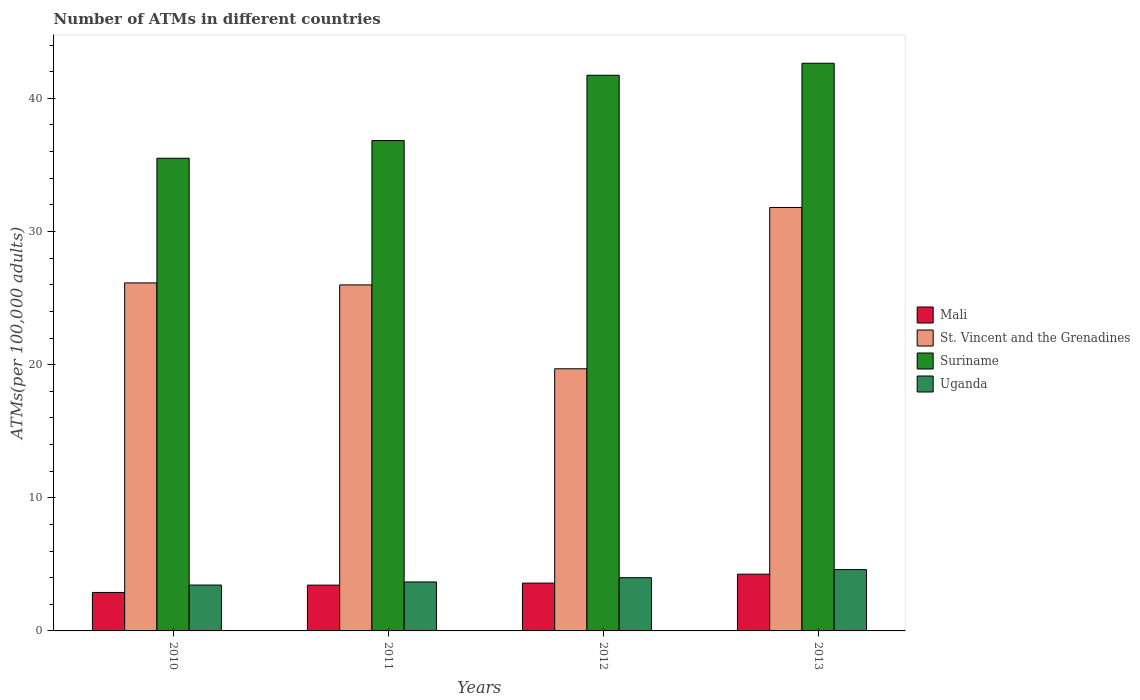How many different coloured bars are there?
Offer a very short reply. 4. How many bars are there on the 4th tick from the right?
Your answer should be very brief. 4. In how many cases, is the number of bars for a given year not equal to the number of legend labels?
Your answer should be compact. 0. What is the number of ATMs in Suriname in 2013?
Offer a very short reply. 42.64. Across all years, what is the maximum number of ATMs in St. Vincent and the Grenadines?
Provide a short and direct response. 31.81. Across all years, what is the minimum number of ATMs in Uganda?
Make the answer very short. 3.45. What is the total number of ATMs in Suriname in the graph?
Make the answer very short. 156.71. What is the difference between the number of ATMs in Mali in 2011 and that in 2013?
Keep it short and to the point. -0.82. What is the difference between the number of ATMs in Uganda in 2011 and the number of ATMs in St. Vincent and the Grenadines in 2010?
Your answer should be compact. -22.46. What is the average number of ATMs in St. Vincent and the Grenadines per year?
Offer a very short reply. 25.91. In the year 2010, what is the difference between the number of ATMs in Uganda and number of ATMs in Mali?
Your answer should be compact. 0.56. What is the ratio of the number of ATMs in Mali in 2012 to that in 2013?
Keep it short and to the point. 0.84. Is the difference between the number of ATMs in Uganda in 2011 and 2012 greater than the difference between the number of ATMs in Mali in 2011 and 2012?
Your answer should be very brief. No. What is the difference between the highest and the second highest number of ATMs in St. Vincent and the Grenadines?
Your answer should be very brief. 5.67. What is the difference between the highest and the lowest number of ATMs in Mali?
Provide a succinct answer. 1.37. In how many years, is the number of ATMs in Uganda greater than the average number of ATMs in Uganda taken over all years?
Provide a short and direct response. 2. Is it the case that in every year, the sum of the number of ATMs in Uganda and number of ATMs in St. Vincent and the Grenadines is greater than the sum of number of ATMs in Mali and number of ATMs in Suriname?
Offer a terse response. Yes. What does the 1st bar from the left in 2011 represents?
Provide a short and direct response. Mali. What does the 1st bar from the right in 2010 represents?
Ensure brevity in your answer.  Uganda. Is it the case that in every year, the sum of the number of ATMs in St. Vincent and the Grenadines and number of ATMs in Mali is greater than the number of ATMs in Suriname?
Your response must be concise. No. Are all the bars in the graph horizontal?
Offer a very short reply. No. How many years are there in the graph?
Make the answer very short. 4. Are the values on the major ticks of Y-axis written in scientific E-notation?
Provide a short and direct response. No. Does the graph contain any zero values?
Offer a terse response. No. Does the graph contain grids?
Make the answer very short. No. How many legend labels are there?
Provide a short and direct response. 4. How are the legend labels stacked?
Keep it short and to the point. Vertical. What is the title of the graph?
Provide a succinct answer. Number of ATMs in different countries. Does "Peru" appear as one of the legend labels in the graph?
Give a very brief answer. No. What is the label or title of the Y-axis?
Make the answer very short. ATMs(per 100,0 adults). What is the ATMs(per 100,000 adults) in Mali in 2010?
Provide a succinct answer. 2.89. What is the ATMs(per 100,000 adults) of St. Vincent and the Grenadines in 2010?
Your answer should be very brief. 26.14. What is the ATMs(per 100,000 adults) of Suriname in 2010?
Keep it short and to the point. 35.5. What is the ATMs(per 100,000 adults) of Uganda in 2010?
Your answer should be compact. 3.45. What is the ATMs(per 100,000 adults) of Mali in 2011?
Your response must be concise. 3.44. What is the ATMs(per 100,000 adults) of St. Vincent and the Grenadines in 2011?
Offer a very short reply. 25.99. What is the ATMs(per 100,000 adults) of Suriname in 2011?
Your answer should be compact. 36.83. What is the ATMs(per 100,000 adults) in Uganda in 2011?
Your answer should be compact. 3.68. What is the ATMs(per 100,000 adults) of Mali in 2012?
Make the answer very short. 3.59. What is the ATMs(per 100,000 adults) of St. Vincent and the Grenadines in 2012?
Offer a very short reply. 19.69. What is the ATMs(per 100,000 adults) of Suriname in 2012?
Your response must be concise. 41.73. What is the ATMs(per 100,000 adults) of Uganda in 2012?
Provide a succinct answer. 4. What is the ATMs(per 100,000 adults) in Mali in 2013?
Give a very brief answer. 4.26. What is the ATMs(per 100,000 adults) of St. Vincent and the Grenadines in 2013?
Ensure brevity in your answer.  31.81. What is the ATMs(per 100,000 adults) in Suriname in 2013?
Your answer should be compact. 42.64. What is the ATMs(per 100,000 adults) of Uganda in 2013?
Ensure brevity in your answer.  4.6. Across all years, what is the maximum ATMs(per 100,000 adults) of Mali?
Ensure brevity in your answer.  4.26. Across all years, what is the maximum ATMs(per 100,000 adults) of St. Vincent and the Grenadines?
Provide a succinct answer. 31.81. Across all years, what is the maximum ATMs(per 100,000 adults) in Suriname?
Give a very brief answer. 42.64. Across all years, what is the maximum ATMs(per 100,000 adults) of Uganda?
Offer a terse response. 4.6. Across all years, what is the minimum ATMs(per 100,000 adults) of Mali?
Your answer should be compact. 2.89. Across all years, what is the minimum ATMs(per 100,000 adults) in St. Vincent and the Grenadines?
Keep it short and to the point. 19.69. Across all years, what is the minimum ATMs(per 100,000 adults) of Suriname?
Make the answer very short. 35.5. Across all years, what is the minimum ATMs(per 100,000 adults) in Uganda?
Ensure brevity in your answer.  3.45. What is the total ATMs(per 100,000 adults) of Mali in the graph?
Your response must be concise. 14.18. What is the total ATMs(per 100,000 adults) of St. Vincent and the Grenadines in the graph?
Your response must be concise. 103.62. What is the total ATMs(per 100,000 adults) in Suriname in the graph?
Ensure brevity in your answer.  156.71. What is the total ATMs(per 100,000 adults) of Uganda in the graph?
Offer a very short reply. 15.73. What is the difference between the ATMs(per 100,000 adults) in Mali in 2010 and that in 2011?
Provide a succinct answer. -0.55. What is the difference between the ATMs(per 100,000 adults) in St. Vincent and the Grenadines in 2010 and that in 2011?
Make the answer very short. 0.15. What is the difference between the ATMs(per 100,000 adults) of Suriname in 2010 and that in 2011?
Your response must be concise. -1.33. What is the difference between the ATMs(per 100,000 adults) in Uganda in 2010 and that in 2011?
Keep it short and to the point. -0.23. What is the difference between the ATMs(per 100,000 adults) of Mali in 2010 and that in 2012?
Provide a short and direct response. -0.7. What is the difference between the ATMs(per 100,000 adults) in St. Vincent and the Grenadines in 2010 and that in 2012?
Your answer should be very brief. 6.45. What is the difference between the ATMs(per 100,000 adults) in Suriname in 2010 and that in 2012?
Offer a very short reply. -6.23. What is the difference between the ATMs(per 100,000 adults) of Uganda in 2010 and that in 2012?
Your answer should be very brief. -0.55. What is the difference between the ATMs(per 100,000 adults) in Mali in 2010 and that in 2013?
Provide a succinct answer. -1.37. What is the difference between the ATMs(per 100,000 adults) of St. Vincent and the Grenadines in 2010 and that in 2013?
Provide a short and direct response. -5.67. What is the difference between the ATMs(per 100,000 adults) of Suriname in 2010 and that in 2013?
Give a very brief answer. -7.13. What is the difference between the ATMs(per 100,000 adults) in Uganda in 2010 and that in 2013?
Keep it short and to the point. -1.16. What is the difference between the ATMs(per 100,000 adults) in Mali in 2011 and that in 2012?
Your answer should be very brief. -0.15. What is the difference between the ATMs(per 100,000 adults) of St. Vincent and the Grenadines in 2011 and that in 2012?
Keep it short and to the point. 6.3. What is the difference between the ATMs(per 100,000 adults) of Suriname in 2011 and that in 2012?
Your response must be concise. -4.9. What is the difference between the ATMs(per 100,000 adults) in Uganda in 2011 and that in 2012?
Make the answer very short. -0.32. What is the difference between the ATMs(per 100,000 adults) of Mali in 2011 and that in 2013?
Offer a very short reply. -0.82. What is the difference between the ATMs(per 100,000 adults) in St. Vincent and the Grenadines in 2011 and that in 2013?
Your answer should be compact. -5.82. What is the difference between the ATMs(per 100,000 adults) in Suriname in 2011 and that in 2013?
Provide a succinct answer. -5.8. What is the difference between the ATMs(per 100,000 adults) in Uganda in 2011 and that in 2013?
Your answer should be very brief. -0.93. What is the difference between the ATMs(per 100,000 adults) in Mali in 2012 and that in 2013?
Make the answer very short. -0.67. What is the difference between the ATMs(per 100,000 adults) in St. Vincent and the Grenadines in 2012 and that in 2013?
Your response must be concise. -12.12. What is the difference between the ATMs(per 100,000 adults) of Suriname in 2012 and that in 2013?
Your answer should be compact. -0.9. What is the difference between the ATMs(per 100,000 adults) of Uganda in 2012 and that in 2013?
Offer a very short reply. -0.61. What is the difference between the ATMs(per 100,000 adults) of Mali in 2010 and the ATMs(per 100,000 adults) of St. Vincent and the Grenadines in 2011?
Ensure brevity in your answer.  -23.1. What is the difference between the ATMs(per 100,000 adults) in Mali in 2010 and the ATMs(per 100,000 adults) in Suriname in 2011?
Your answer should be very brief. -33.95. What is the difference between the ATMs(per 100,000 adults) of Mali in 2010 and the ATMs(per 100,000 adults) of Uganda in 2011?
Provide a short and direct response. -0.79. What is the difference between the ATMs(per 100,000 adults) of St. Vincent and the Grenadines in 2010 and the ATMs(per 100,000 adults) of Suriname in 2011?
Ensure brevity in your answer.  -10.7. What is the difference between the ATMs(per 100,000 adults) in St. Vincent and the Grenadines in 2010 and the ATMs(per 100,000 adults) in Uganda in 2011?
Give a very brief answer. 22.46. What is the difference between the ATMs(per 100,000 adults) of Suriname in 2010 and the ATMs(per 100,000 adults) of Uganda in 2011?
Provide a succinct answer. 31.82. What is the difference between the ATMs(per 100,000 adults) of Mali in 2010 and the ATMs(per 100,000 adults) of St. Vincent and the Grenadines in 2012?
Give a very brief answer. -16.8. What is the difference between the ATMs(per 100,000 adults) of Mali in 2010 and the ATMs(per 100,000 adults) of Suriname in 2012?
Keep it short and to the point. -38.84. What is the difference between the ATMs(per 100,000 adults) of Mali in 2010 and the ATMs(per 100,000 adults) of Uganda in 2012?
Give a very brief answer. -1.11. What is the difference between the ATMs(per 100,000 adults) of St. Vincent and the Grenadines in 2010 and the ATMs(per 100,000 adults) of Suriname in 2012?
Your answer should be compact. -15.6. What is the difference between the ATMs(per 100,000 adults) in St. Vincent and the Grenadines in 2010 and the ATMs(per 100,000 adults) in Uganda in 2012?
Keep it short and to the point. 22.14. What is the difference between the ATMs(per 100,000 adults) of Suriname in 2010 and the ATMs(per 100,000 adults) of Uganda in 2012?
Your answer should be compact. 31.5. What is the difference between the ATMs(per 100,000 adults) of Mali in 2010 and the ATMs(per 100,000 adults) of St. Vincent and the Grenadines in 2013?
Keep it short and to the point. -28.92. What is the difference between the ATMs(per 100,000 adults) of Mali in 2010 and the ATMs(per 100,000 adults) of Suriname in 2013?
Keep it short and to the point. -39.75. What is the difference between the ATMs(per 100,000 adults) of Mali in 2010 and the ATMs(per 100,000 adults) of Uganda in 2013?
Offer a terse response. -1.72. What is the difference between the ATMs(per 100,000 adults) of St. Vincent and the Grenadines in 2010 and the ATMs(per 100,000 adults) of Suriname in 2013?
Your answer should be very brief. -16.5. What is the difference between the ATMs(per 100,000 adults) in St. Vincent and the Grenadines in 2010 and the ATMs(per 100,000 adults) in Uganda in 2013?
Give a very brief answer. 21.53. What is the difference between the ATMs(per 100,000 adults) of Suriname in 2010 and the ATMs(per 100,000 adults) of Uganda in 2013?
Provide a short and direct response. 30.9. What is the difference between the ATMs(per 100,000 adults) of Mali in 2011 and the ATMs(per 100,000 adults) of St. Vincent and the Grenadines in 2012?
Make the answer very short. -16.25. What is the difference between the ATMs(per 100,000 adults) of Mali in 2011 and the ATMs(per 100,000 adults) of Suriname in 2012?
Your answer should be compact. -38.29. What is the difference between the ATMs(per 100,000 adults) of Mali in 2011 and the ATMs(per 100,000 adults) of Uganda in 2012?
Your answer should be very brief. -0.56. What is the difference between the ATMs(per 100,000 adults) of St. Vincent and the Grenadines in 2011 and the ATMs(per 100,000 adults) of Suriname in 2012?
Make the answer very short. -15.75. What is the difference between the ATMs(per 100,000 adults) in St. Vincent and the Grenadines in 2011 and the ATMs(per 100,000 adults) in Uganda in 2012?
Provide a succinct answer. 21.99. What is the difference between the ATMs(per 100,000 adults) in Suriname in 2011 and the ATMs(per 100,000 adults) in Uganda in 2012?
Offer a terse response. 32.84. What is the difference between the ATMs(per 100,000 adults) of Mali in 2011 and the ATMs(per 100,000 adults) of St. Vincent and the Grenadines in 2013?
Your response must be concise. -28.37. What is the difference between the ATMs(per 100,000 adults) of Mali in 2011 and the ATMs(per 100,000 adults) of Suriname in 2013?
Your answer should be very brief. -39.2. What is the difference between the ATMs(per 100,000 adults) of Mali in 2011 and the ATMs(per 100,000 adults) of Uganda in 2013?
Your answer should be very brief. -1.17. What is the difference between the ATMs(per 100,000 adults) in St. Vincent and the Grenadines in 2011 and the ATMs(per 100,000 adults) in Suriname in 2013?
Your answer should be very brief. -16.65. What is the difference between the ATMs(per 100,000 adults) in St. Vincent and the Grenadines in 2011 and the ATMs(per 100,000 adults) in Uganda in 2013?
Provide a short and direct response. 21.38. What is the difference between the ATMs(per 100,000 adults) of Suriname in 2011 and the ATMs(per 100,000 adults) of Uganda in 2013?
Your answer should be very brief. 32.23. What is the difference between the ATMs(per 100,000 adults) in Mali in 2012 and the ATMs(per 100,000 adults) in St. Vincent and the Grenadines in 2013?
Give a very brief answer. -28.21. What is the difference between the ATMs(per 100,000 adults) in Mali in 2012 and the ATMs(per 100,000 adults) in Suriname in 2013?
Provide a short and direct response. -39.04. What is the difference between the ATMs(per 100,000 adults) in Mali in 2012 and the ATMs(per 100,000 adults) in Uganda in 2013?
Make the answer very short. -1.01. What is the difference between the ATMs(per 100,000 adults) of St. Vincent and the Grenadines in 2012 and the ATMs(per 100,000 adults) of Suriname in 2013?
Your answer should be very brief. -22.95. What is the difference between the ATMs(per 100,000 adults) of St. Vincent and the Grenadines in 2012 and the ATMs(per 100,000 adults) of Uganda in 2013?
Keep it short and to the point. 15.09. What is the difference between the ATMs(per 100,000 adults) in Suriname in 2012 and the ATMs(per 100,000 adults) in Uganda in 2013?
Offer a terse response. 37.13. What is the average ATMs(per 100,000 adults) in Mali per year?
Make the answer very short. 3.55. What is the average ATMs(per 100,000 adults) in St. Vincent and the Grenadines per year?
Your response must be concise. 25.91. What is the average ATMs(per 100,000 adults) of Suriname per year?
Give a very brief answer. 39.18. What is the average ATMs(per 100,000 adults) of Uganda per year?
Offer a terse response. 3.93. In the year 2010, what is the difference between the ATMs(per 100,000 adults) of Mali and ATMs(per 100,000 adults) of St. Vincent and the Grenadines?
Your answer should be compact. -23.25. In the year 2010, what is the difference between the ATMs(per 100,000 adults) of Mali and ATMs(per 100,000 adults) of Suriname?
Provide a succinct answer. -32.61. In the year 2010, what is the difference between the ATMs(per 100,000 adults) of Mali and ATMs(per 100,000 adults) of Uganda?
Your response must be concise. -0.56. In the year 2010, what is the difference between the ATMs(per 100,000 adults) of St. Vincent and the Grenadines and ATMs(per 100,000 adults) of Suriname?
Offer a very short reply. -9.36. In the year 2010, what is the difference between the ATMs(per 100,000 adults) of St. Vincent and the Grenadines and ATMs(per 100,000 adults) of Uganda?
Give a very brief answer. 22.69. In the year 2010, what is the difference between the ATMs(per 100,000 adults) in Suriname and ATMs(per 100,000 adults) in Uganda?
Provide a succinct answer. 32.06. In the year 2011, what is the difference between the ATMs(per 100,000 adults) of Mali and ATMs(per 100,000 adults) of St. Vincent and the Grenadines?
Offer a terse response. -22.55. In the year 2011, what is the difference between the ATMs(per 100,000 adults) in Mali and ATMs(per 100,000 adults) in Suriname?
Your response must be concise. -33.4. In the year 2011, what is the difference between the ATMs(per 100,000 adults) in Mali and ATMs(per 100,000 adults) in Uganda?
Make the answer very short. -0.24. In the year 2011, what is the difference between the ATMs(per 100,000 adults) in St. Vincent and the Grenadines and ATMs(per 100,000 adults) in Suriname?
Your response must be concise. -10.85. In the year 2011, what is the difference between the ATMs(per 100,000 adults) of St. Vincent and the Grenadines and ATMs(per 100,000 adults) of Uganda?
Provide a succinct answer. 22.31. In the year 2011, what is the difference between the ATMs(per 100,000 adults) of Suriname and ATMs(per 100,000 adults) of Uganda?
Make the answer very short. 33.16. In the year 2012, what is the difference between the ATMs(per 100,000 adults) in Mali and ATMs(per 100,000 adults) in St. Vincent and the Grenadines?
Your response must be concise. -16.1. In the year 2012, what is the difference between the ATMs(per 100,000 adults) in Mali and ATMs(per 100,000 adults) in Suriname?
Your answer should be compact. -38.14. In the year 2012, what is the difference between the ATMs(per 100,000 adults) of Mali and ATMs(per 100,000 adults) of Uganda?
Give a very brief answer. -0.41. In the year 2012, what is the difference between the ATMs(per 100,000 adults) in St. Vincent and the Grenadines and ATMs(per 100,000 adults) in Suriname?
Make the answer very short. -22.04. In the year 2012, what is the difference between the ATMs(per 100,000 adults) in St. Vincent and the Grenadines and ATMs(per 100,000 adults) in Uganda?
Your answer should be compact. 15.69. In the year 2012, what is the difference between the ATMs(per 100,000 adults) in Suriname and ATMs(per 100,000 adults) in Uganda?
Ensure brevity in your answer.  37.73. In the year 2013, what is the difference between the ATMs(per 100,000 adults) in Mali and ATMs(per 100,000 adults) in St. Vincent and the Grenadines?
Give a very brief answer. -27.54. In the year 2013, what is the difference between the ATMs(per 100,000 adults) of Mali and ATMs(per 100,000 adults) of Suriname?
Make the answer very short. -38.37. In the year 2013, what is the difference between the ATMs(per 100,000 adults) in Mali and ATMs(per 100,000 adults) in Uganda?
Offer a terse response. -0.34. In the year 2013, what is the difference between the ATMs(per 100,000 adults) in St. Vincent and the Grenadines and ATMs(per 100,000 adults) in Suriname?
Ensure brevity in your answer.  -10.83. In the year 2013, what is the difference between the ATMs(per 100,000 adults) of St. Vincent and the Grenadines and ATMs(per 100,000 adults) of Uganda?
Offer a terse response. 27.2. In the year 2013, what is the difference between the ATMs(per 100,000 adults) in Suriname and ATMs(per 100,000 adults) in Uganda?
Offer a terse response. 38.03. What is the ratio of the ATMs(per 100,000 adults) in Mali in 2010 to that in 2011?
Offer a terse response. 0.84. What is the ratio of the ATMs(per 100,000 adults) in Suriname in 2010 to that in 2011?
Make the answer very short. 0.96. What is the ratio of the ATMs(per 100,000 adults) in Uganda in 2010 to that in 2011?
Your answer should be very brief. 0.94. What is the ratio of the ATMs(per 100,000 adults) of Mali in 2010 to that in 2012?
Your response must be concise. 0.8. What is the ratio of the ATMs(per 100,000 adults) of St. Vincent and the Grenadines in 2010 to that in 2012?
Offer a very short reply. 1.33. What is the ratio of the ATMs(per 100,000 adults) in Suriname in 2010 to that in 2012?
Offer a very short reply. 0.85. What is the ratio of the ATMs(per 100,000 adults) in Uganda in 2010 to that in 2012?
Your answer should be very brief. 0.86. What is the ratio of the ATMs(per 100,000 adults) of Mali in 2010 to that in 2013?
Give a very brief answer. 0.68. What is the ratio of the ATMs(per 100,000 adults) of St. Vincent and the Grenadines in 2010 to that in 2013?
Offer a terse response. 0.82. What is the ratio of the ATMs(per 100,000 adults) of Suriname in 2010 to that in 2013?
Your response must be concise. 0.83. What is the ratio of the ATMs(per 100,000 adults) in Uganda in 2010 to that in 2013?
Keep it short and to the point. 0.75. What is the ratio of the ATMs(per 100,000 adults) of Mali in 2011 to that in 2012?
Offer a very short reply. 0.96. What is the ratio of the ATMs(per 100,000 adults) in St. Vincent and the Grenadines in 2011 to that in 2012?
Offer a very short reply. 1.32. What is the ratio of the ATMs(per 100,000 adults) of Suriname in 2011 to that in 2012?
Offer a very short reply. 0.88. What is the ratio of the ATMs(per 100,000 adults) of Uganda in 2011 to that in 2012?
Your answer should be very brief. 0.92. What is the ratio of the ATMs(per 100,000 adults) in Mali in 2011 to that in 2013?
Provide a short and direct response. 0.81. What is the ratio of the ATMs(per 100,000 adults) of St. Vincent and the Grenadines in 2011 to that in 2013?
Provide a succinct answer. 0.82. What is the ratio of the ATMs(per 100,000 adults) in Suriname in 2011 to that in 2013?
Make the answer very short. 0.86. What is the ratio of the ATMs(per 100,000 adults) in Uganda in 2011 to that in 2013?
Your answer should be compact. 0.8. What is the ratio of the ATMs(per 100,000 adults) in Mali in 2012 to that in 2013?
Give a very brief answer. 0.84. What is the ratio of the ATMs(per 100,000 adults) in St. Vincent and the Grenadines in 2012 to that in 2013?
Your answer should be compact. 0.62. What is the ratio of the ATMs(per 100,000 adults) of Suriname in 2012 to that in 2013?
Give a very brief answer. 0.98. What is the ratio of the ATMs(per 100,000 adults) in Uganda in 2012 to that in 2013?
Offer a terse response. 0.87. What is the difference between the highest and the second highest ATMs(per 100,000 adults) of Mali?
Keep it short and to the point. 0.67. What is the difference between the highest and the second highest ATMs(per 100,000 adults) in St. Vincent and the Grenadines?
Provide a short and direct response. 5.67. What is the difference between the highest and the second highest ATMs(per 100,000 adults) of Suriname?
Make the answer very short. 0.9. What is the difference between the highest and the second highest ATMs(per 100,000 adults) in Uganda?
Your answer should be compact. 0.61. What is the difference between the highest and the lowest ATMs(per 100,000 adults) of Mali?
Ensure brevity in your answer.  1.37. What is the difference between the highest and the lowest ATMs(per 100,000 adults) of St. Vincent and the Grenadines?
Your response must be concise. 12.12. What is the difference between the highest and the lowest ATMs(per 100,000 adults) in Suriname?
Your answer should be very brief. 7.13. What is the difference between the highest and the lowest ATMs(per 100,000 adults) of Uganda?
Provide a succinct answer. 1.16. 